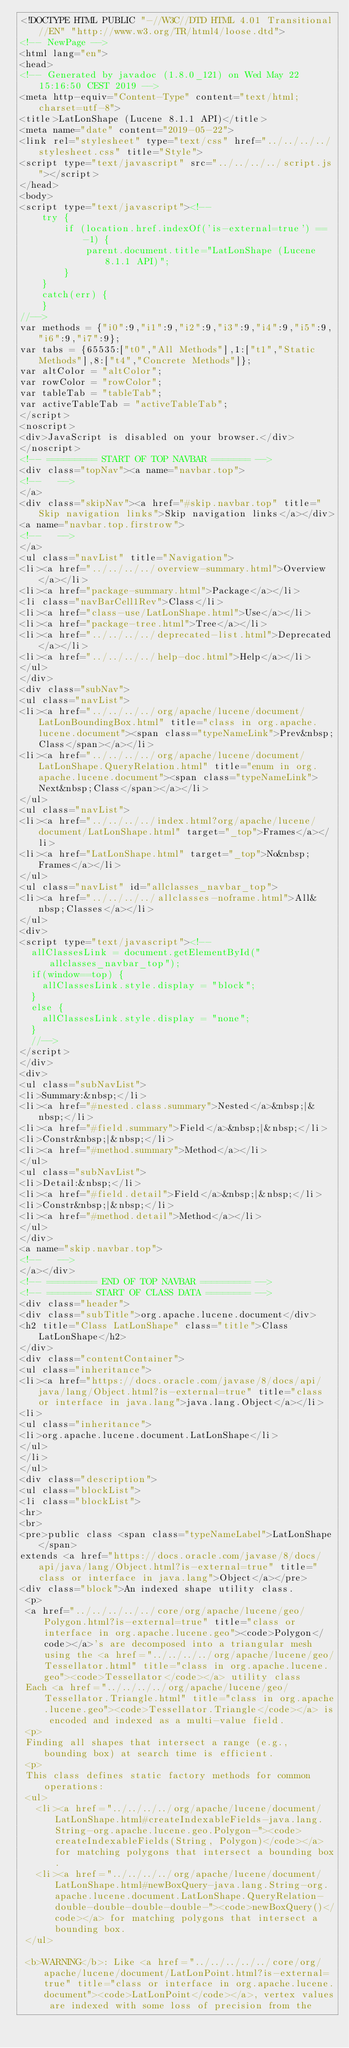Convert code to text. <code><loc_0><loc_0><loc_500><loc_500><_HTML_><!DOCTYPE HTML PUBLIC "-//W3C//DTD HTML 4.01 Transitional//EN" "http://www.w3.org/TR/html4/loose.dtd">
<!-- NewPage -->
<html lang="en">
<head>
<!-- Generated by javadoc (1.8.0_121) on Wed May 22 15:16:50 CEST 2019 -->
<meta http-equiv="Content-Type" content="text/html; charset=utf-8">
<title>LatLonShape (Lucene 8.1.1 API)</title>
<meta name="date" content="2019-05-22">
<link rel="stylesheet" type="text/css" href="../../../../stylesheet.css" title="Style">
<script type="text/javascript" src="../../../../script.js"></script>
</head>
<body>
<script type="text/javascript"><!--
    try {
        if (location.href.indexOf('is-external=true') == -1) {
            parent.document.title="LatLonShape (Lucene 8.1.1 API)";
        }
    }
    catch(err) {
    }
//-->
var methods = {"i0":9,"i1":9,"i2":9,"i3":9,"i4":9,"i5":9,"i6":9,"i7":9};
var tabs = {65535:["t0","All Methods"],1:["t1","Static Methods"],8:["t4","Concrete Methods"]};
var altColor = "altColor";
var rowColor = "rowColor";
var tableTab = "tableTab";
var activeTableTab = "activeTableTab";
</script>
<noscript>
<div>JavaScript is disabled on your browser.</div>
</noscript>
<!-- ========= START OF TOP NAVBAR ======= -->
<div class="topNav"><a name="navbar.top">
<!--   -->
</a>
<div class="skipNav"><a href="#skip.navbar.top" title="Skip navigation links">Skip navigation links</a></div>
<a name="navbar.top.firstrow">
<!--   -->
</a>
<ul class="navList" title="Navigation">
<li><a href="../../../../overview-summary.html">Overview</a></li>
<li><a href="package-summary.html">Package</a></li>
<li class="navBarCell1Rev">Class</li>
<li><a href="class-use/LatLonShape.html">Use</a></li>
<li><a href="package-tree.html">Tree</a></li>
<li><a href="../../../../deprecated-list.html">Deprecated</a></li>
<li><a href="../../../../help-doc.html">Help</a></li>
</ul>
</div>
<div class="subNav">
<ul class="navList">
<li><a href="../../../../org/apache/lucene/document/LatLonBoundingBox.html" title="class in org.apache.lucene.document"><span class="typeNameLink">Prev&nbsp;Class</span></a></li>
<li><a href="../../../../org/apache/lucene/document/LatLonShape.QueryRelation.html" title="enum in org.apache.lucene.document"><span class="typeNameLink">Next&nbsp;Class</span></a></li>
</ul>
<ul class="navList">
<li><a href="../../../../index.html?org/apache/lucene/document/LatLonShape.html" target="_top">Frames</a></li>
<li><a href="LatLonShape.html" target="_top">No&nbsp;Frames</a></li>
</ul>
<ul class="navList" id="allclasses_navbar_top">
<li><a href="../../../../allclasses-noframe.html">All&nbsp;Classes</a></li>
</ul>
<div>
<script type="text/javascript"><!--
  allClassesLink = document.getElementById("allclasses_navbar_top");
  if(window==top) {
    allClassesLink.style.display = "block";
  }
  else {
    allClassesLink.style.display = "none";
  }
  //-->
</script>
</div>
<div>
<ul class="subNavList">
<li>Summary:&nbsp;</li>
<li><a href="#nested.class.summary">Nested</a>&nbsp;|&nbsp;</li>
<li><a href="#field.summary">Field</a>&nbsp;|&nbsp;</li>
<li>Constr&nbsp;|&nbsp;</li>
<li><a href="#method.summary">Method</a></li>
</ul>
<ul class="subNavList">
<li>Detail:&nbsp;</li>
<li><a href="#field.detail">Field</a>&nbsp;|&nbsp;</li>
<li>Constr&nbsp;|&nbsp;</li>
<li><a href="#method.detail">Method</a></li>
</ul>
</div>
<a name="skip.navbar.top">
<!--   -->
</a></div>
<!-- ========= END OF TOP NAVBAR ========= -->
<!-- ======== START OF CLASS DATA ======== -->
<div class="header">
<div class="subTitle">org.apache.lucene.document</div>
<h2 title="Class LatLonShape" class="title">Class LatLonShape</h2>
</div>
<div class="contentContainer">
<ul class="inheritance">
<li><a href="https://docs.oracle.com/javase/8/docs/api/java/lang/Object.html?is-external=true" title="class or interface in java.lang">java.lang.Object</a></li>
<li>
<ul class="inheritance">
<li>org.apache.lucene.document.LatLonShape</li>
</ul>
</li>
</ul>
<div class="description">
<ul class="blockList">
<li class="blockList">
<hr>
<br>
<pre>public class <span class="typeNameLabel">LatLonShape</span>
extends <a href="https://docs.oracle.com/javase/8/docs/api/java/lang/Object.html?is-external=true" title="class or interface in java.lang">Object</a></pre>
<div class="block">An indexed shape utility class.
 <p>
 <a href="../../../../../core/org/apache/lucene/geo/Polygon.html?is-external=true" title="class or interface in org.apache.lucene.geo"><code>Polygon</code></a>'s are decomposed into a triangular mesh using the <a href="../../../../org/apache/lucene/geo/Tessellator.html" title="class in org.apache.lucene.geo"><code>Tessellator</code></a> utility class
 Each <a href="../../../../org/apache/lucene/geo/Tessellator.Triangle.html" title="class in org.apache.lucene.geo"><code>Tessellator.Triangle</code></a> is encoded and indexed as a multi-value field.
 <p>
 Finding all shapes that intersect a range (e.g., bounding box) at search time is efficient.
 <p>
 This class defines static factory methods for common operations:
 <ul>
   <li><a href="../../../../org/apache/lucene/document/LatLonShape.html#createIndexableFields-java.lang.String-org.apache.lucene.geo.Polygon-"><code>createIndexableFields(String, Polygon)</code></a> for matching polygons that intersect a bounding box.
   <li><a href="../../../../org/apache/lucene/document/LatLonShape.html#newBoxQuery-java.lang.String-org.apache.lucene.document.LatLonShape.QueryRelation-double-double-double-double-"><code>newBoxQuery()</code></a> for matching polygons that intersect a bounding box.
 </ul>

 <b>WARNING</b>: Like <a href="../../../../../core/org/apache/lucene/document/LatLonPoint.html?is-external=true" title="class or interface in org.apache.lucene.document"><code>LatLonPoint</code></a>, vertex values are indexed with some loss of precision from the</code> 